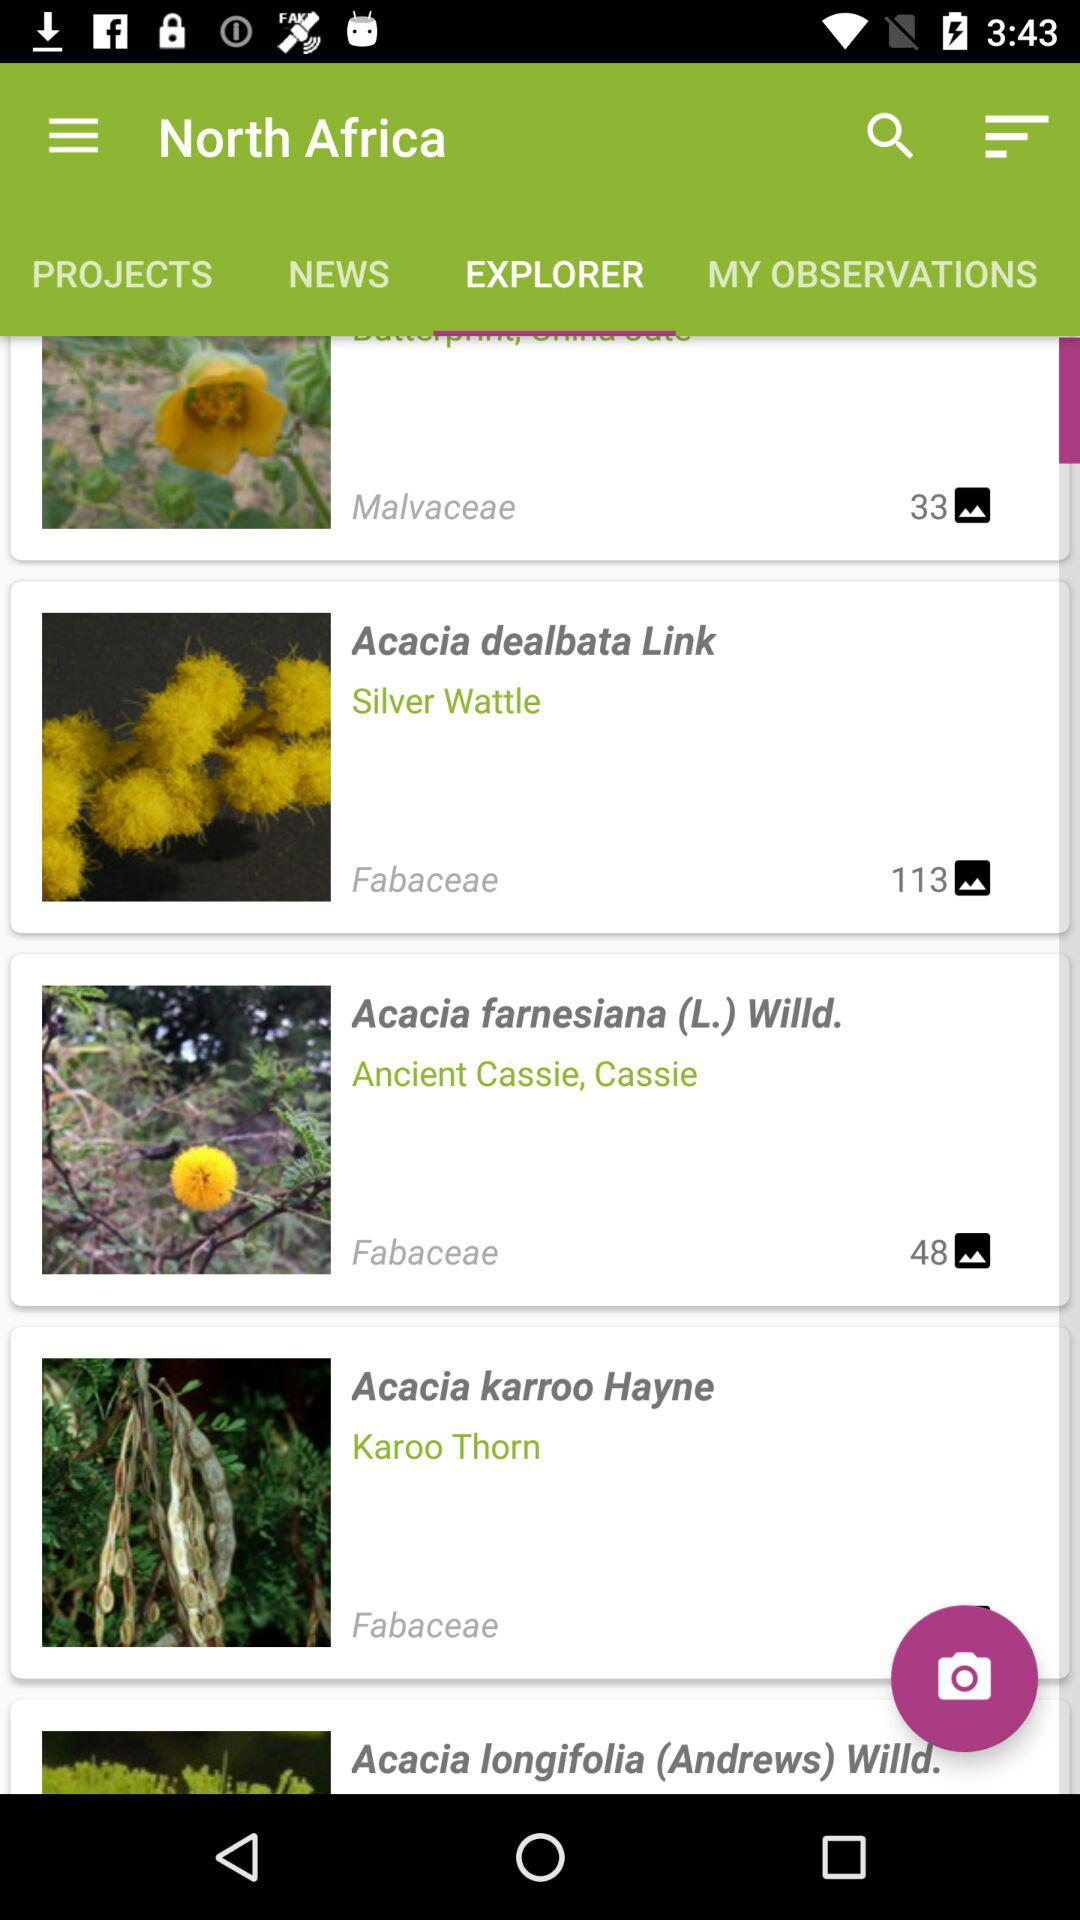Explain how users can contribute their observations in the app. Users can contribute by clicking on the camera icon at the bottom of the screen, which allows them to upload pictures of plants they encounter. Each uploaded observation can be tagged with the plant's name, location, and other details. This feature not only enriches the database but also helps in community-driven data collection and sharing. 